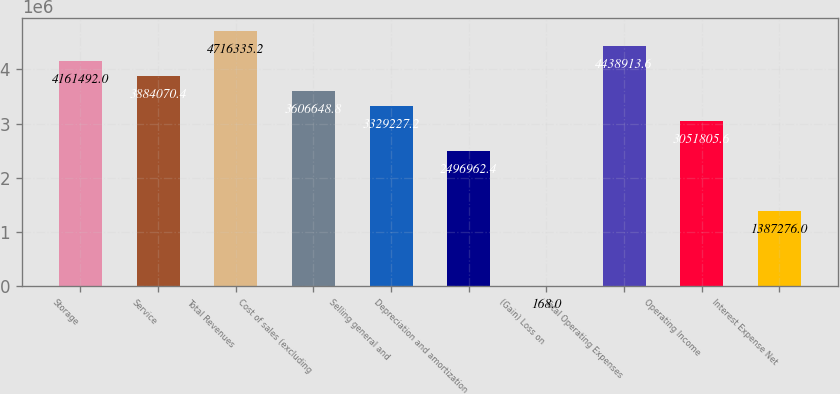Convert chart to OTSL. <chart><loc_0><loc_0><loc_500><loc_500><bar_chart><fcel>Storage<fcel>Service<fcel>Total Revenues<fcel>Cost of sales (excluding<fcel>Selling general and<fcel>Depreciation and amortization<fcel>(Gain) Loss on<fcel>Total Operating Expenses<fcel>Operating Income<fcel>Interest Expense Net<nl><fcel>4.16149e+06<fcel>3.88407e+06<fcel>4.71634e+06<fcel>3.60665e+06<fcel>3.32923e+06<fcel>2.49696e+06<fcel>168<fcel>4.43891e+06<fcel>3.05181e+06<fcel>1.38728e+06<nl></chart> 